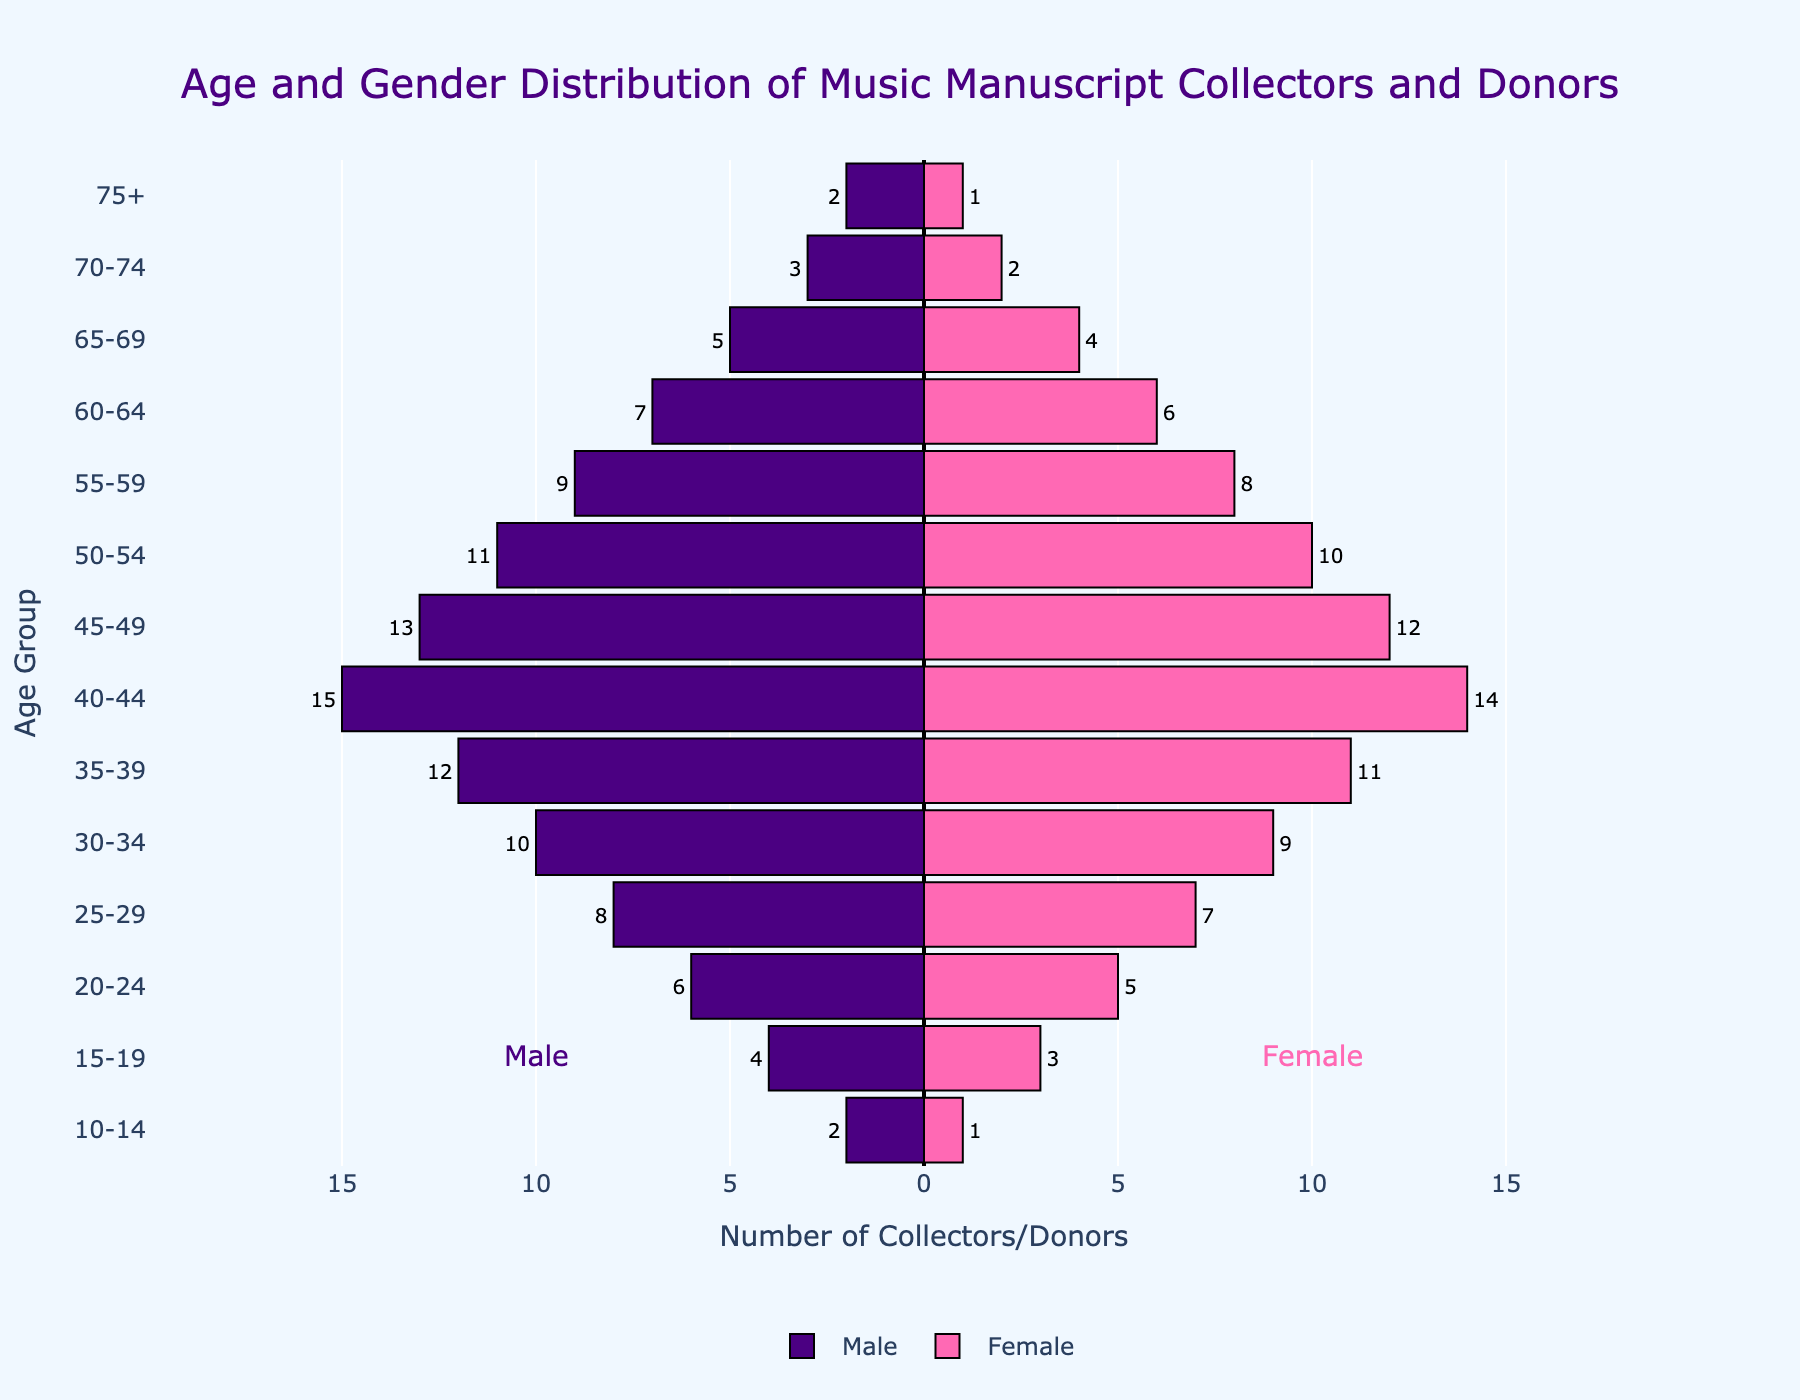1. What is the title of the figure? Look at the top of the figure where the title is clearly displayed in a larger font.
Answer: Age and Gender Distribution of Music Manuscript Collectors and Donors 2. How many males are in the 55-59 age group? Locate the "55-59" age group on the y-axis and reference the length of the corresponding bar on the left (male side). The bar is labeled with the number 9.
Answer: 9 3. Which age group has the highest number of female collectors and donors? Scan the figure to see which female bar (right side) extends the farthest. The 40-44 age group has the longest bar with 14 females.
Answer: 40-44 4. How many more males are there than females in the 45-49 age group? Look at the "45-49" age group and compare the male and female bars. There are 13 males and 12 females. Subtract the number of females from males: 13 - 12 = 1.
Answer: 1 5. What is the total number of collectors and donors in the 30-34 age group? Identify the 30-34 group and sum the values of male (10) and female (9): 10 + 9 = 19.
Answer: 19 6. Which gender has a higher number of collectors and donors in the 20-24 age group, and by how much? Check the 20-24 age group and compare the male and female bars. There are 6 males and 5 females. Calculate the difference: 6 - 5 = 1. Males have a higher count.
Answer: Males by 1 7. What is the average number of female collectors and donors across all age groups? Sum the values for females across all age groups (1+2+4+6+8+10+12+14+11+9+7+5+3+1 = 93), then divide by the number of age groups (14): 93 / 14 ≈ 6.64.
Answer: Approximately 6.64 8. Are there any age groups with an equal number of male and female collectors and donors? Inspect each age group to see if the male and female bars are of equal length. In this data set, such an equal pairing does not exist.
Answer: No 9. Which age group has the smallest total number of collectors and donors? Sum the numbers of males and females for each age group and identify the smallest sum. The "10-14" age group has a total of 3 (2 males + 1 female), which is the smallest.
Answer: 10-14 10. What is the overall trend in the number of collectors and donors as age increases? Observe the figure to see how the lengths of the bars change from younger to older age groups. The number of collectors and donors generally decreases as age increases.
Answer: Decreases 